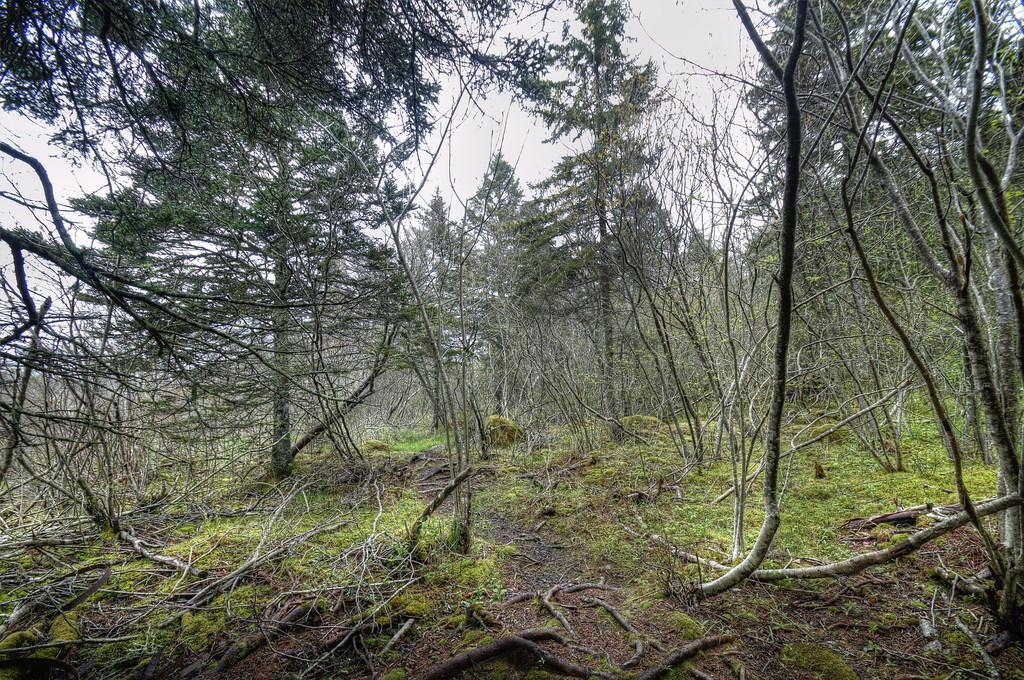Where was the image taken? The image was taken outdoors. What type of ground is visible in the image? There is a ground with grass in the image. What can be seen in the background of the image? There are many trees in the image. What is visible at the top of the image? The sky is visible at the top of the image. What type of treatment is being administered to the trees in the image? There is no treatment being administered to the trees in the image; they appear to be healthy and growing naturally. 